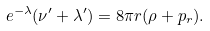<formula> <loc_0><loc_0><loc_500><loc_500>e ^ { - \lambda } ( \nu ^ { \prime } + \lambda ^ { \prime } ) = 8 \pi r ( \rho + p _ { r } ) .</formula> 